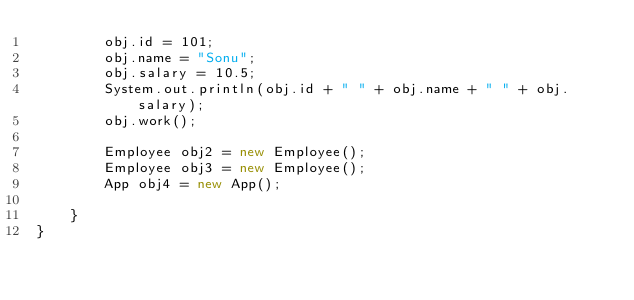Convert code to text. <code><loc_0><loc_0><loc_500><loc_500><_Java_>		obj.id = 101;
		obj.name = "Sonu";
		obj.salary = 10.5;
		System.out.println(obj.id + " " + obj.name + " " + obj.salary);
		obj.work();

		Employee obj2 = new Employee();
		Employee obj3 = new Employee();
		App obj4 = new App();

	}
}
</code> 